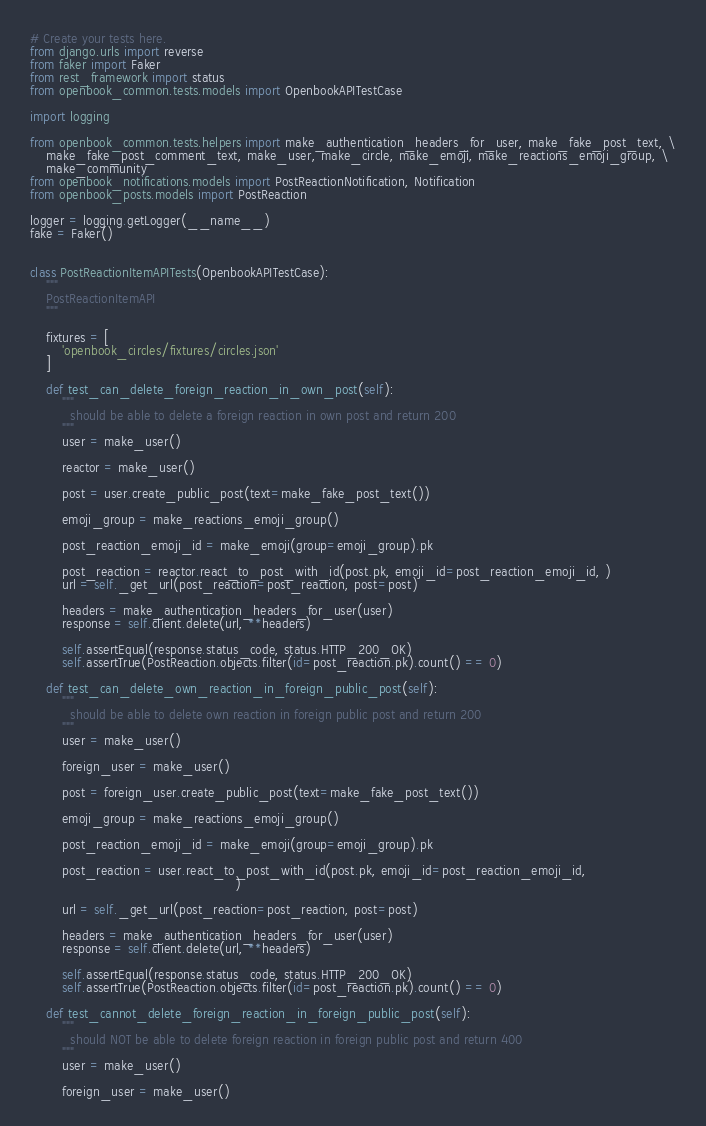<code> <loc_0><loc_0><loc_500><loc_500><_Python_># Create your tests here.
from django.urls import reverse
from faker import Faker
from rest_framework import status
from openbook_common.tests.models import OpenbookAPITestCase

import logging

from openbook_common.tests.helpers import make_authentication_headers_for_user, make_fake_post_text, \
    make_fake_post_comment_text, make_user, make_circle, make_emoji, make_reactions_emoji_group, \
    make_community
from openbook_notifications.models import PostReactionNotification, Notification
from openbook_posts.models import PostReaction

logger = logging.getLogger(__name__)
fake = Faker()


class PostReactionItemAPITests(OpenbookAPITestCase):
    """
    PostReactionItemAPI
    """

    fixtures = [
        'openbook_circles/fixtures/circles.json'
    ]

    def test_can_delete_foreign_reaction_in_own_post(self):
        """
          should be able to delete a foreign reaction in own post and return 200
        """
        user = make_user()

        reactor = make_user()

        post = user.create_public_post(text=make_fake_post_text())

        emoji_group = make_reactions_emoji_group()

        post_reaction_emoji_id = make_emoji(group=emoji_group).pk

        post_reaction = reactor.react_to_post_with_id(post.pk, emoji_id=post_reaction_emoji_id, )
        url = self._get_url(post_reaction=post_reaction, post=post)

        headers = make_authentication_headers_for_user(user)
        response = self.client.delete(url, **headers)

        self.assertEqual(response.status_code, status.HTTP_200_OK)
        self.assertTrue(PostReaction.objects.filter(id=post_reaction.pk).count() == 0)

    def test_can_delete_own_reaction_in_foreign_public_post(self):
        """
          should be able to delete own reaction in foreign public post and return 200
        """
        user = make_user()

        foreign_user = make_user()

        post = foreign_user.create_public_post(text=make_fake_post_text())

        emoji_group = make_reactions_emoji_group()

        post_reaction_emoji_id = make_emoji(group=emoji_group).pk

        post_reaction = user.react_to_post_with_id(post.pk, emoji_id=post_reaction_emoji_id,
                                                   )

        url = self._get_url(post_reaction=post_reaction, post=post)

        headers = make_authentication_headers_for_user(user)
        response = self.client.delete(url, **headers)

        self.assertEqual(response.status_code, status.HTTP_200_OK)
        self.assertTrue(PostReaction.objects.filter(id=post_reaction.pk).count() == 0)

    def test_cannot_delete_foreign_reaction_in_foreign_public_post(self):
        """
          should NOT be able to delete foreign reaction in foreign public post and return 400
        """
        user = make_user()

        foreign_user = make_user()
</code> 